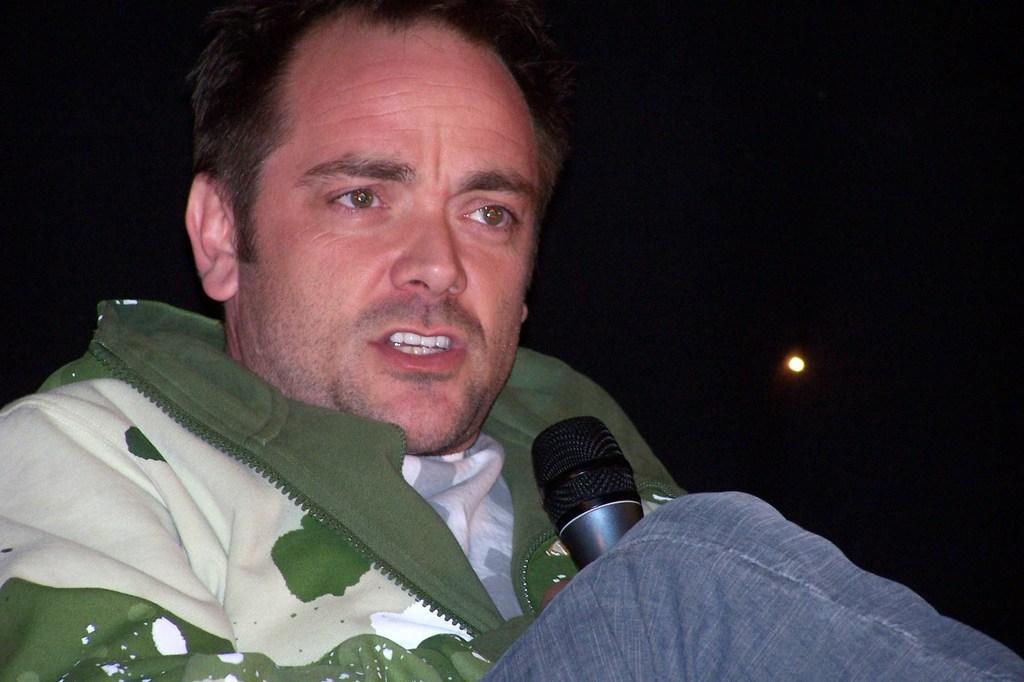Describe this image in one or two sentences. In this image there is a person with green and white jacket and blue jeans. He is holding a microphone and he is talking 